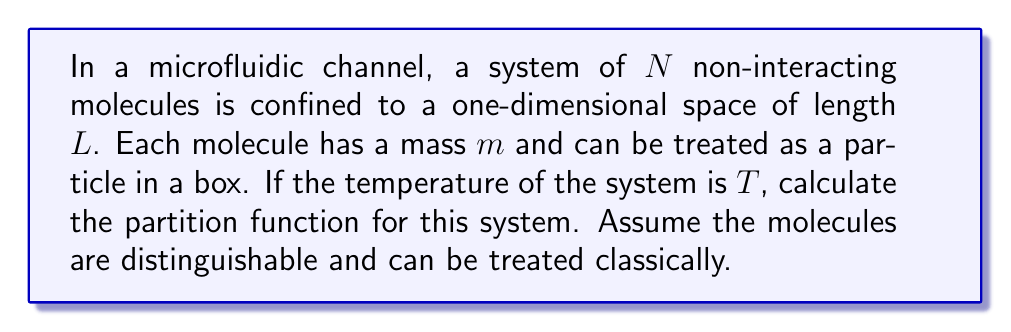Give your solution to this math problem. Let's approach this step-by-step:

1) For a single particle in a one-dimensional box of length $L$, the energy levels are given by:

   $$E_n = \frac{n^2h^2}{8mL^2}$$

   where $n$ is a positive integer, $h$ is Planck's constant, and $m$ is the mass of the particle.

2) The partition function for a single particle is:

   $$z = \sum_{n=1}^{\infty} e^{-\beta E_n}$$

   where $\beta = \frac{1}{k_BT}$, $k_B$ is Boltzmann's constant, and $T$ is the temperature.

3) In the classical limit (high temperature or large $L$), we can approximate this sum with an integral:

   $$z \approx \frac{L}{h} \sqrt{2\pi m k_BT}$$

4) For a system of $N$ distinguishable particles, the total partition function $Z$ is the product of the individual partition functions:

   $$Z = z^N$$

5) Substituting the expression for $z$:

   $$Z = \left(\frac{L}{h} \sqrt{2\pi m k_BT}\right)^N$$

6) This can be rewritten as:

   $$Z = \frac{L^N}{h^N} (2\pi m k_BT)^{N/2}$$

This is the partition function for the system of molecules in the microfluidic channel.
Answer: $$Z = \frac{L^N}{h^N} (2\pi m k_BT)^{N/2}$$ 